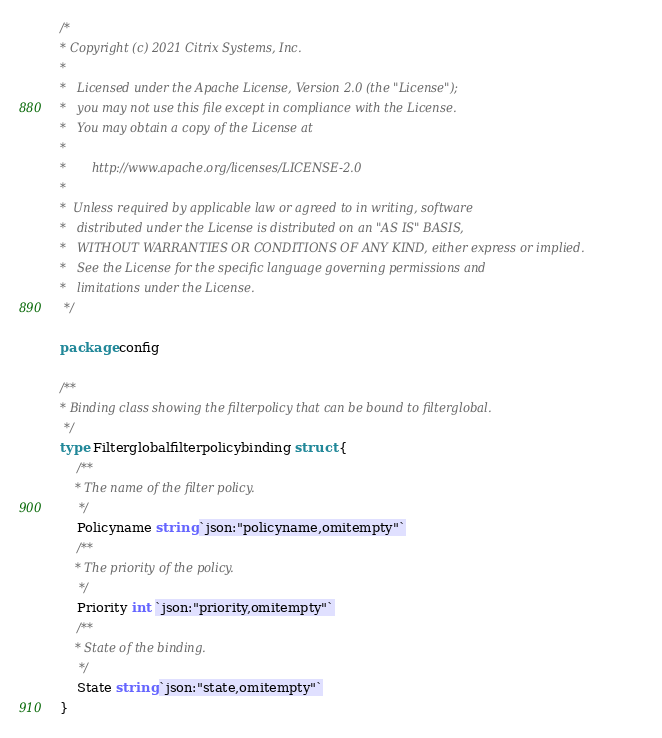Convert code to text. <code><loc_0><loc_0><loc_500><loc_500><_Go_>/*
* Copyright (c) 2021 Citrix Systems, Inc.
*
*   Licensed under the Apache License, Version 2.0 (the "License");
*   you may not use this file except in compliance with the License.
*   You may obtain a copy of the License at
*
*       http://www.apache.org/licenses/LICENSE-2.0
*
*  Unless required by applicable law or agreed to in writing, software
*   distributed under the License is distributed on an "AS IS" BASIS,
*   WITHOUT WARRANTIES OR CONDITIONS OF ANY KIND, either express or implied.
*   See the License for the specific language governing permissions and
*   limitations under the License.
 */

package config

/**
* Binding class showing the filterpolicy that can be bound to filterglobal.
 */
type Filterglobalfilterpolicybinding struct {
	/**
	* The name of the filter policy.
	 */
	Policyname string `json:"policyname,omitempty"`
	/**
	* The priority of the policy.
	 */
	Priority int `json:"priority,omitempty"`
	/**
	* State of the binding.
	 */
	State string `json:"state,omitempty"`
}
</code> 